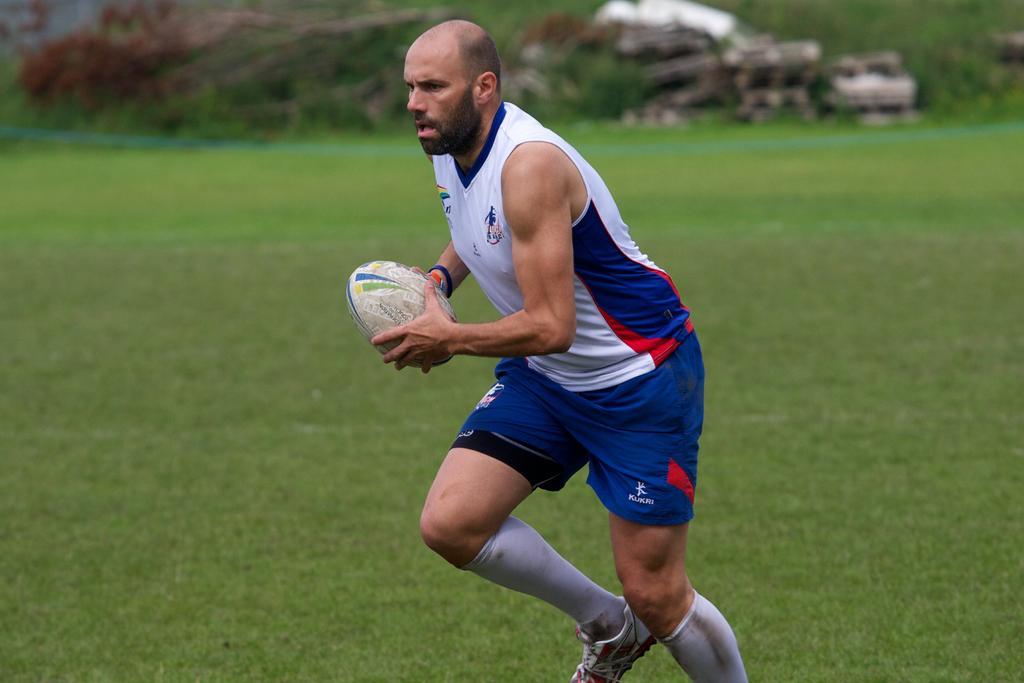In one or two sentences, can you explain what this image depicts? In this image there is a person with white and blue t-shirt, he is holding the ball and he is running. At the bottom there is a grass, at the back there are plants. This is the picture of the playground. 